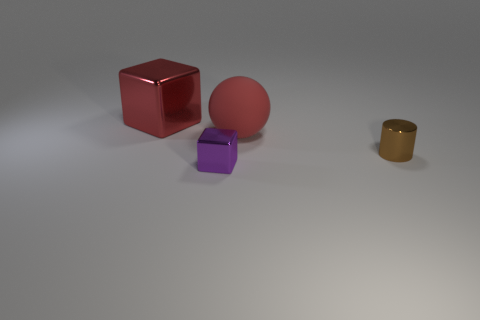Subtract all red blocks. How many blocks are left? 1 Subtract all cylinders. How many objects are left? 3 Add 3 matte objects. How many objects exist? 7 Subtract all cyan balls. How many red blocks are left? 1 Add 4 large yellow metal cylinders. How many large yellow metal cylinders exist? 4 Subtract 0 yellow balls. How many objects are left? 4 Subtract 1 blocks. How many blocks are left? 1 Subtract all gray cylinders. Subtract all gray blocks. How many cylinders are left? 1 Subtract all blocks. Subtract all shiny balls. How many objects are left? 2 Add 1 tiny metallic things. How many tiny metallic things are left? 3 